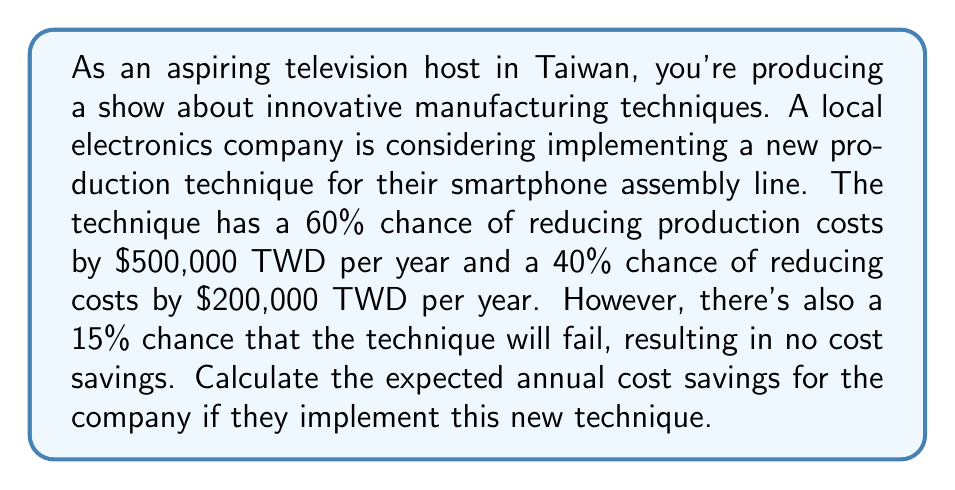Can you solve this math problem? Let's approach this step-by-step:

1) First, we need to identify the possible outcomes and their probabilities:
   - 60% chance of $500,000 TWD savings
   - 40% chance of $200,000 TWD savings
   - 15% chance of no savings (failure)

2) Note that the probabilities of success (60% + 40% = 100%) and failure (15%) sum to 115%. This means the 15% chance of failure is independent of the success scenarios.

3) To calculate the expected value, we need to adjust the probabilities of the success scenarios:
   - Probability of $500,000 savings: 60% * (1 - 15%) = 60% * 85% = 51%
   - Probability of $200,000 savings: 40% * (1 - 15%) = 40% * 85% = 34%
   - Probability of no savings: 15%

4) Now we can calculate the expected value:
   $$ E = (0.51 * 500,000) + (0.34 * 200,000) + (0.15 * 0) $$

5) Let's compute each term:
   $$ E = 255,000 + 68,000 + 0 $$

6) Sum up the terms:
   $$ E = 323,000 $$

Therefore, the expected annual cost savings is $323,000 TWD.
Answer: $323,000 TWD 